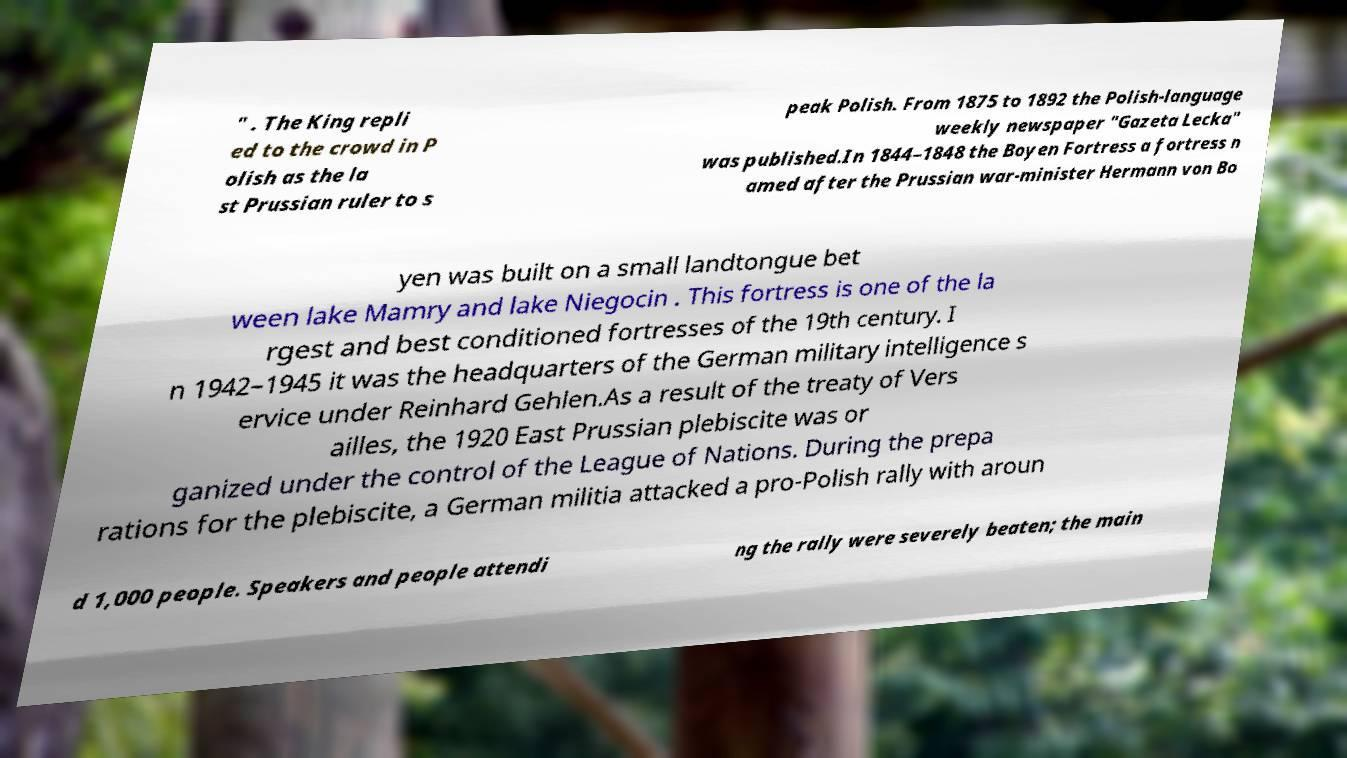Could you extract and type out the text from this image? " . The King repli ed to the crowd in P olish as the la st Prussian ruler to s peak Polish. From 1875 to 1892 the Polish-language weekly newspaper "Gazeta Lecka" was published.In 1844–1848 the Boyen Fortress a fortress n amed after the Prussian war-minister Hermann von Bo yen was built on a small landtongue bet ween lake Mamry and lake Niegocin . This fortress is one of the la rgest and best conditioned fortresses of the 19th century. I n 1942–1945 it was the headquarters of the German military intelligence s ervice under Reinhard Gehlen.As a result of the treaty of Vers ailles, the 1920 East Prussian plebiscite was or ganized under the control of the League of Nations. During the prepa rations for the plebiscite, a German militia attacked a pro-Polish rally with aroun d 1,000 people. Speakers and people attendi ng the rally were severely beaten; the main 